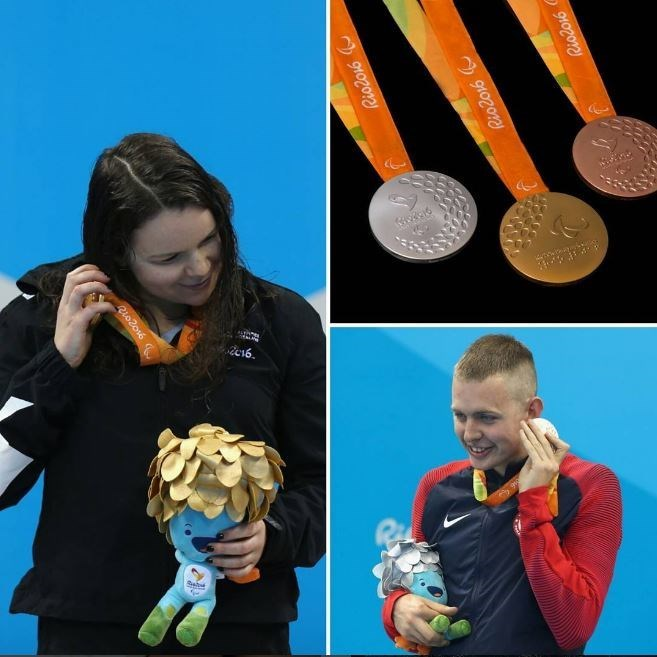What is the significance of the mascots the athletes are holding? The mascots the athletes are holding are significant souvenirs representing the Rio 2016 Olympic Games. Each mascot embodies the spirit and culture of the host city, Rio de Janeiro. The plush toys the athletes hold are designed to be cheerful and colorful, often inspired by local flora, fauna, or folklore. They serve not only as mementos of participation but also symbolize the unity, diversity, and celebratory nature of the Olympic Games. 